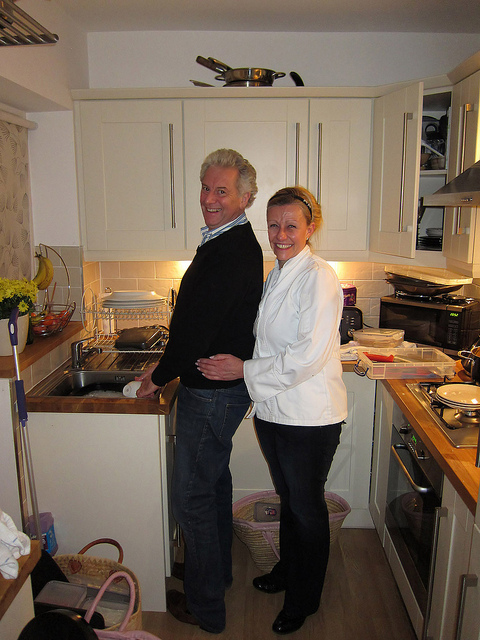<image>Is the stove full? I am not sure if the stove is full. It cannot be seen in the entire stove. Is the stove full? I don't know if the stove is full. It is not clear from the given information. 